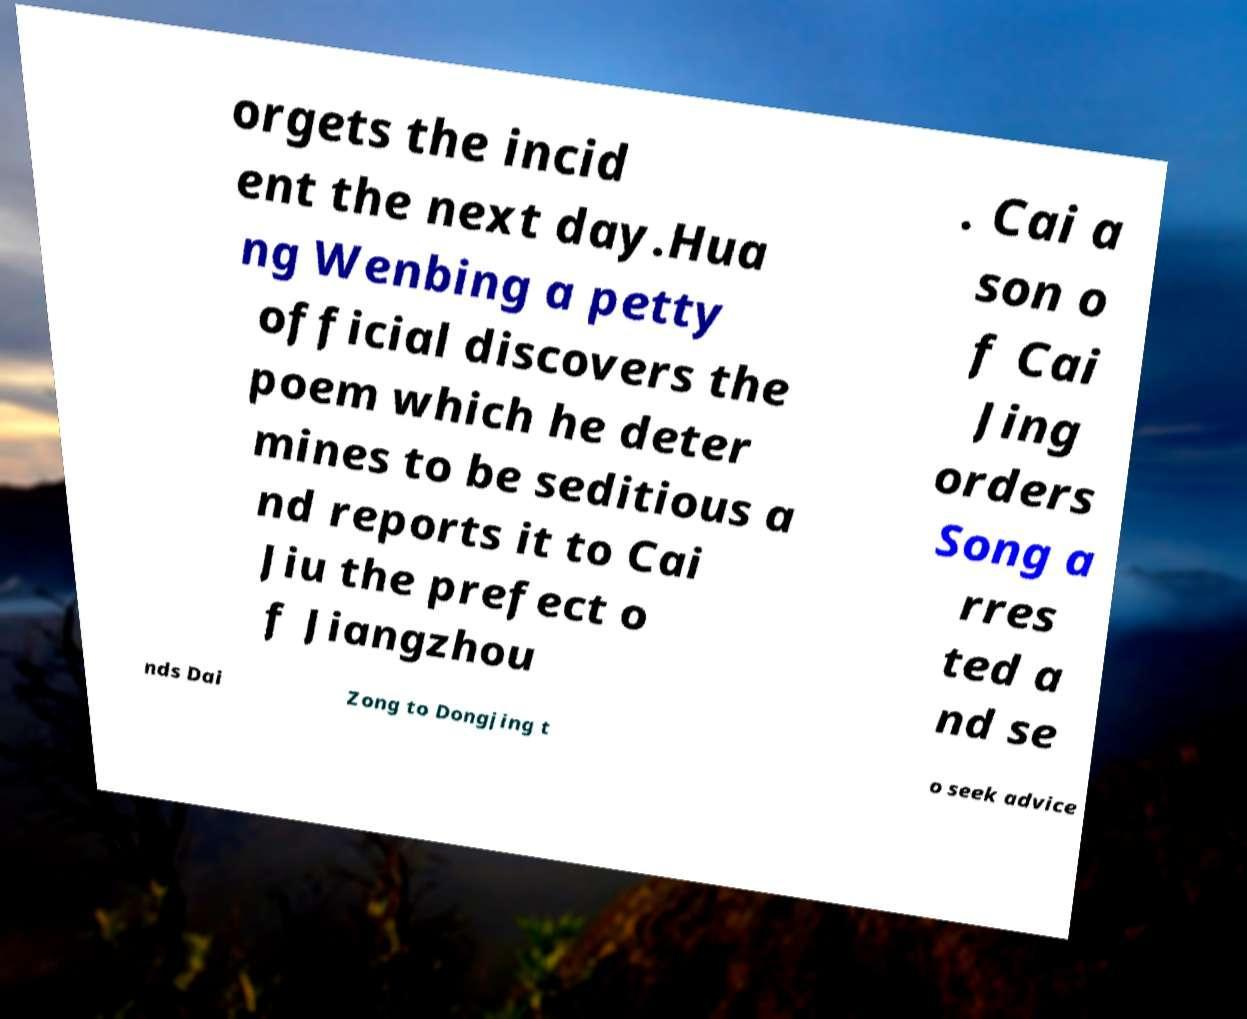Please read and relay the text visible in this image. What does it say? orgets the incid ent the next day.Hua ng Wenbing a petty official discovers the poem which he deter mines to be seditious a nd reports it to Cai Jiu the prefect o f Jiangzhou . Cai a son o f Cai Jing orders Song a rres ted a nd se nds Dai Zong to Dongjing t o seek advice 